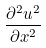<formula> <loc_0><loc_0><loc_500><loc_500>\frac { \partial ^ { 2 } u ^ { 2 } } { \partial x ^ { 2 } }</formula> 